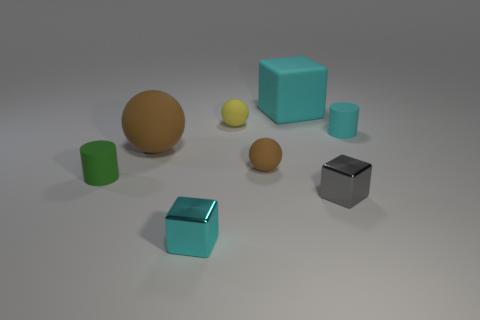Subtract all tiny brown spheres. How many spheres are left? 2 Add 2 big rubber spheres. How many objects exist? 10 Subtract all cyan cubes. How many brown spheres are left? 2 Subtract all spheres. How many objects are left? 5 Subtract 1 spheres. How many spheres are left? 2 Subtract all brown cylinders. Subtract all brown cubes. How many cylinders are left? 2 Subtract all cyan shiny things. Subtract all cyan cubes. How many objects are left? 5 Add 7 tiny cyan things. How many tiny cyan things are left? 9 Add 8 blue shiny cubes. How many blue shiny cubes exist? 8 Subtract 1 yellow balls. How many objects are left? 7 